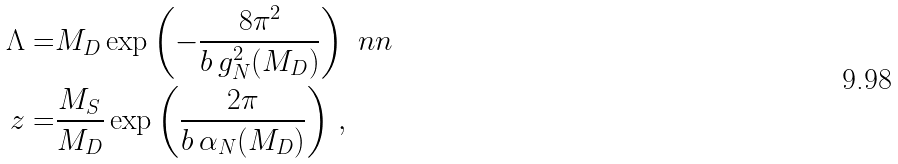Convert formula to latex. <formula><loc_0><loc_0><loc_500><loc_500>\Lambda = & M _ { D } \exp \left ( - \frac { 8 \pi ^ { 2 } } { b \, g ^ { 2 } _ { N } ( M _ { D } ) } \right ) \ n n \\ z = & \frac { M _ { S } } { M _ { D } } \exp \left ( \frac { 2 \pi } { b \, \alpha _ { N } ( M _ { D } ) } \right ) \, ,</formula> 